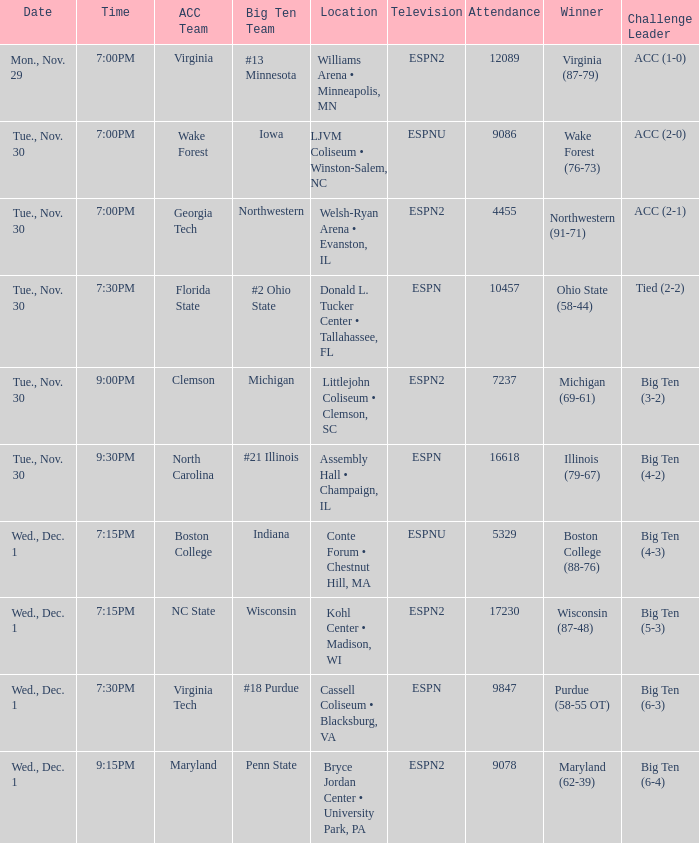Where did the contests involving wisconsin as a big ten team occur? Kohl Center • Madison, WI. 